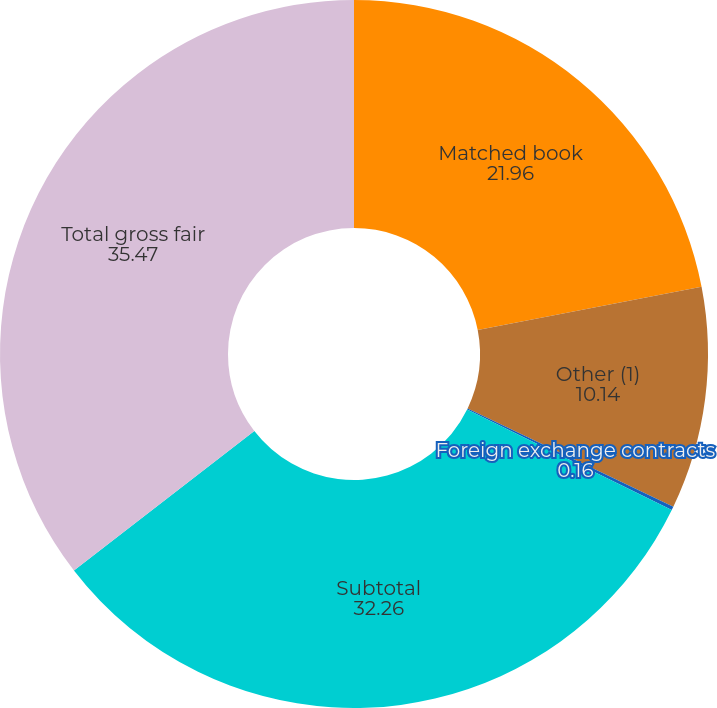<chart> <loc_0><loc_0><loc_500><loc_500><pie_chart><fcel>Matched book<fcel>Other (1)<fcel>Foreign exchange contracts<fcel>Subtotal<fcel>Total gross fair<nl><fcel>21.96%<fcel>10.14%<fcel>0.16%<fcel>32.26%<fcel>35.47%<nl></chart> 